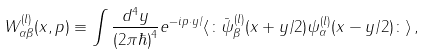Convert formula to latex. <formula><loc_0><loc_0><loc_500><loc_500>W _ { \alpha \beta } ^ { ( l ) } ( x , p ) \equiv \int \frac { d ^ { 4 } y } { ( 2 \pi \hbar { ) } ^ { 4 } } e ^ { - i p \cdot y / } \langle \colon \bar { \psi } _ { \beta } ^ { ( l ) } ( x + y / 2 ) \psi _ { \alpha } ^ { ( l ) } ( x - y / 2 ) \colon \rangle \, ,</formula> 